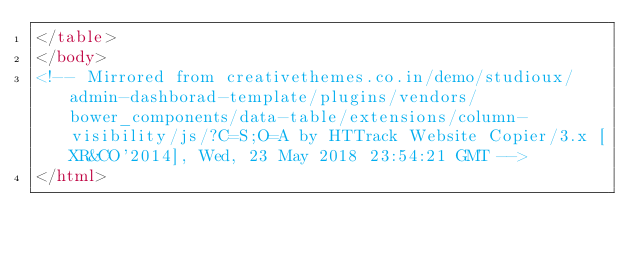Convert code to text. <code><loc_0><loc_0><loc_500><loc_500><_HTML_></table>
</body>
<!-- Mirrored from creativethemes.co.in/demo/studioux/admin-dashborad-template/plugins/vendors/bower_components/data-table/extensions/column-visibility/js/?C=S;O=A by HTTrack Website Copier/3.x [XR&CO'2014], Wed, 23 May 2018 23:54:21 GMT -->
</html>
</code> 